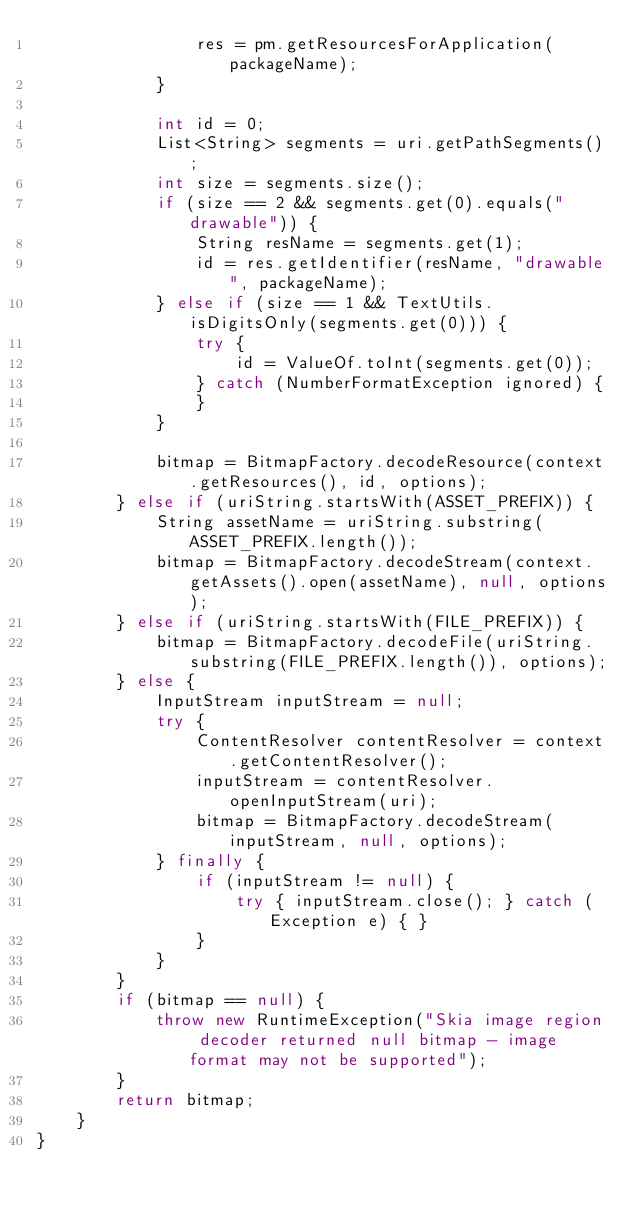<code> <loc_0><loc_0><loc_500><loc_500><_Java_>                res = pm.getResourcesForApplication(packageName);
            }

            int id = 0;
            List<String> segments = uri.getPathSegments();
            int size = segments.size();
            if (size == 2 && segments.get(0).equals("drawable")) {
                String resName = segments.get(1);
                id = res.getIdentifier(resName, "drawable", packageName);
            } else if (size == 1 && TextUtils.isDigitsOnly(segments.get(0))) {
                try {
                    id = ValueOf.toInt(segments.get(0));
                } catch (NumberFormatException ignored) {
                }
            }

            bitmap = BitmapFactory.decodeResource(context.getResources(), id, options);
        } else if (uriString.startsWith(ASSET_PREFIX)) {
            String assetName = uriString.substring(ASSET_PREFIX.length());
            bitmap = BitmapFactory.decodeStream(context.getAssets().open(assetName), null, options);
        } else if (uriString.startsWith(FILE_PREFIX)) {
            bitmap = BitmapFactory.decodeFile(uriString.substring(FILE_PREFIX.length()), options);
        } else {
            InputStream inputStream = null;
            try {
                ContentResolver contentResolver = context.getContentResolver();
                inputStream = contentResolver.openInputStream(uri);
                bitmap = BitmapFactory.decodeStream(inputStream, null, options);
            } finally {
                if (inputStream != null) {
                    try { inputStream.close(); } catch (Exception e) { }
                }
            }
        }
        if (bitmap == null) {
            throw new RuntimeException("Skia image region decoder returned null bitmap - image format may not be supported");
        }
        return bitmap;
    }
}
</code> 